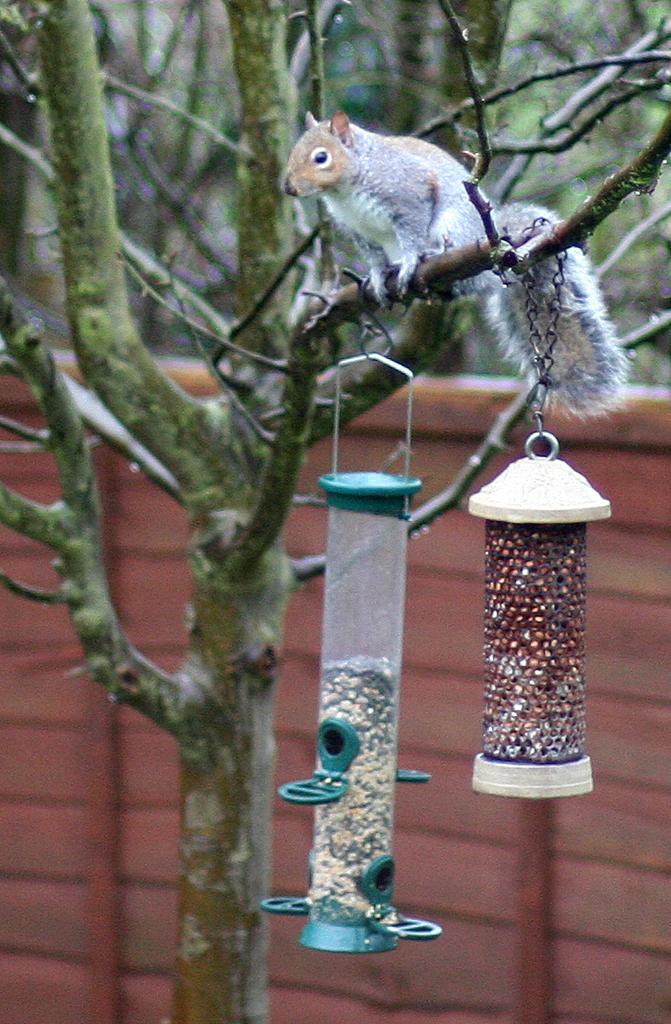Can you describe this image briefly? In this image we can see a squirrel. We can also see the tree with two objects hanging. In the background we can see the wall. 